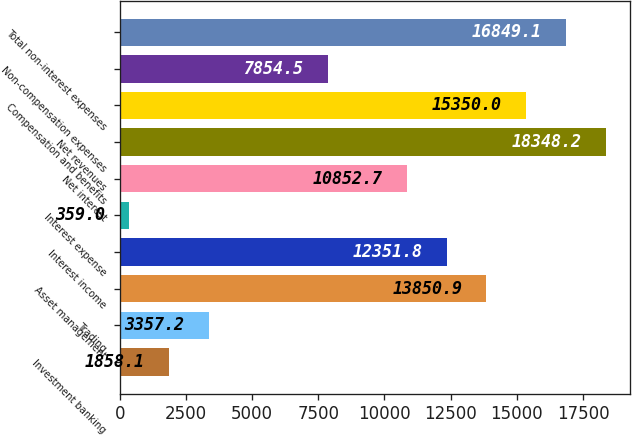<chart> <loc_0><loc_0><loc_500><loc_500><bar_chart><fcel>Investment banking<fcel>Trading<fcel>Asset management<fcel>Interest income<fcel>Interest expense<fcel>Net interest<fcel>Net revenues<fcel>Compensation and benefits<fcel>Non-compensation expenses<fcel>Total non-interest expenses<nl><fcel>1858.1<fcel>3357.2<fcel>13850.9<fcel>12351.8<fcel>359<fcel>10852.7<fcel>18348.2<fcel>15350<fcel>7854.5<fcel>16849.1<nl></chart> 